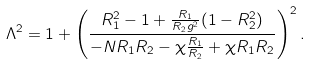Convert formula to latex. <formula><loc_0><loc_0><loc_500><loc_500>\Lambda ^ { 2 } = { 1 + \left ( \frac { R _ { 1 } ^ { 2 } - 1 + \frac { R _ { 1 } } { R _ { 2 } g ^ { 2 } } ( 1 - R _ { 2 } ^ { 2 } ) } { - N R _ { 1 } R _ { 2 } - \chi \frac { R _ { 1 } } { R _ { 2 } } + \chi R _ { 1 } R _ { 2 } } \right ) ^ { 2 } } \, .</formula> 